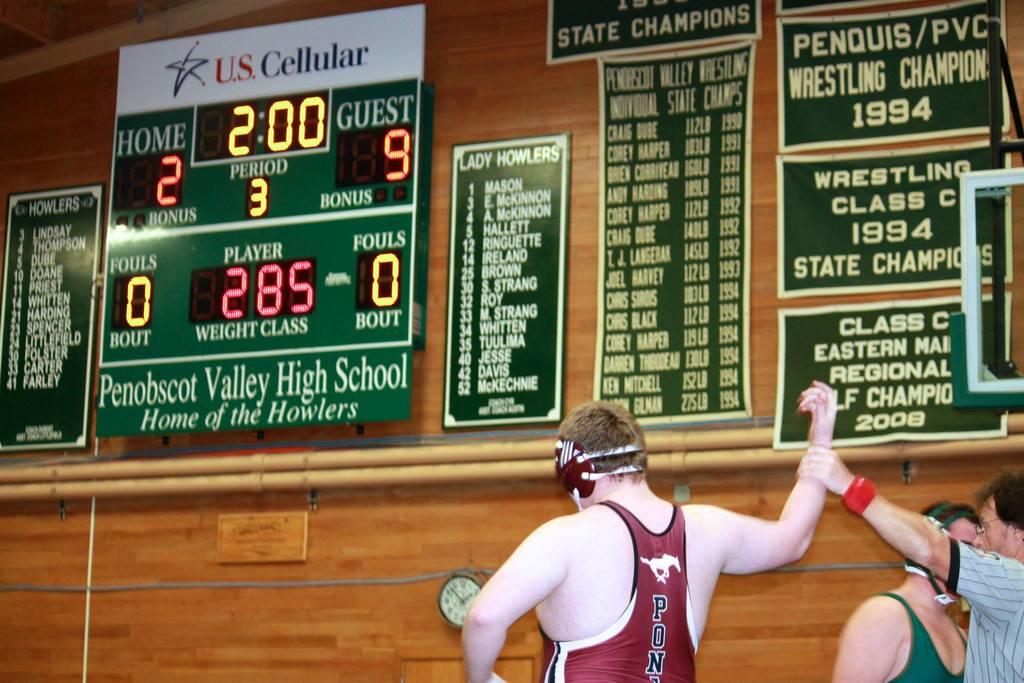What school is this event at?
Ensure brevity in your answer.  Penobscot valley high school. 